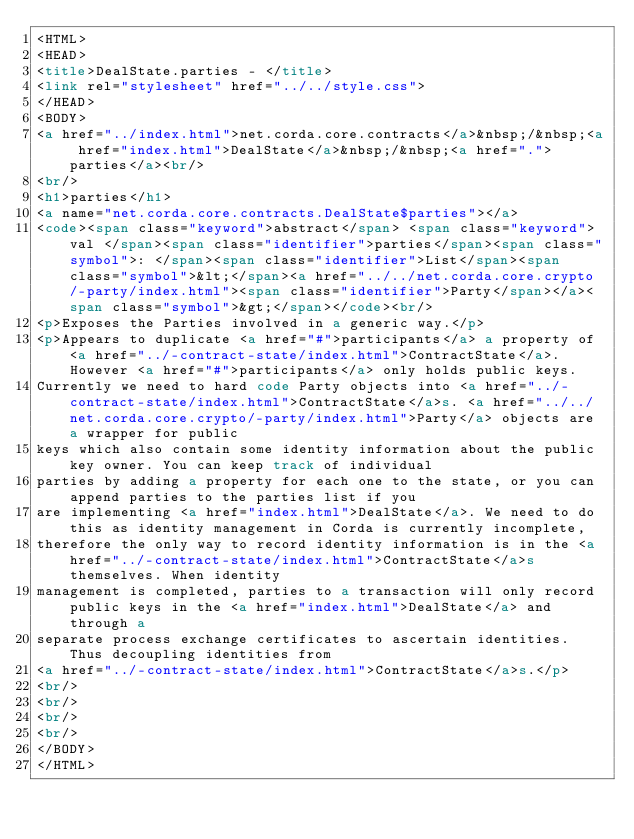Convert code to text. <code><loc_0><loc_0><loc_500><loc_500><_HTML_><HTML>
<HEAD>
<title>DealState.parties - </title>
<link rel="stylesheet" href="../../style.css">
</HEAD>
<BODY>
<a href="../index.html">net.corda.core.contracts</a>&nbsp;/&nbsp;<a href="index.html">DealState</a>&nbsp;/&nbsp;<a href=".">parties</a><br/>
<br/>
<h1>parties</h1>
<a name="net.corda.core.contracts.DealState$parties"></a>
<code><span class="keyword">abstract</span> <span class="keyword">val </span><span class="identifier">parties</span><span class="symbol">: </span><span class="identifier">List</span><span class="symbol">&lt;</span><a href="../../net.corda.core.crypto/-party/index.html"><span class="identifier">Party</span></a><span class="symbol">&gt;</span></code><br/>
<p>Exposes the Parties involved in a generic way.</p>
<p>Appears to duplicate <a href="#">participants</a> a property of <a href="../-contract-state/index.html">ContractState</a>. However <a href="#">participants</a> only holds public keys.
Currently we need to hard code Party objects into <a href="../-contract-state/index.html">ContractState</a>s. <a href="../../net.corda.core.crypto/-party/index.html">Party</a> objects are a wrapper for public
keys which also contain some identity information about the public key owner. You can keep track of individual
parties by adding a property for each one to the state, or you can append parties to the parties list if you
are implementing <a href="index.html">DealState</a>. We need to do this as identity management in Corda is currently incomplete,
therefore the only way to record identity information is in the <a href="../-contract-state/index.html">ContractState</a>s themselves. When identity
management is completed, parties to a transaction will only record public keys in the <a href="index.html">DealState</a> and through a
separate process exchange certificates to ascertain identities. Thus decoupling identities from
<a href="../-contract-state/index.html">ContractState</a>s.</p>
<br/>
<br/>
<br/>
<br/>
</BODY>
</HTML>
</code> 